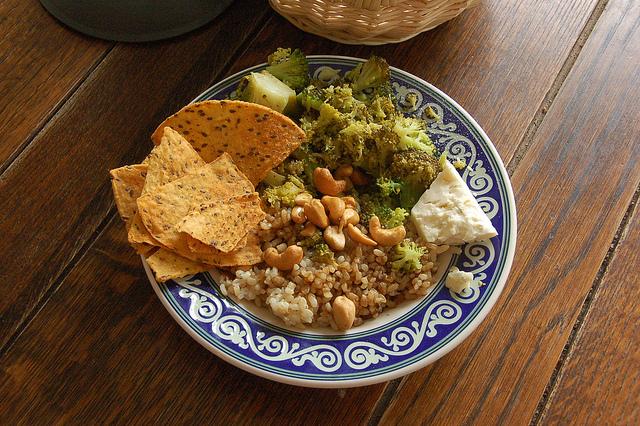What is the table made of?
Give a very brief answer. Wood. What type of plate is that?
Short answer required. Ceramic. Do you see a potato in the picture?
Answer briefly. No. What is the green vegetable?
Concise answer only. Broccoli. 